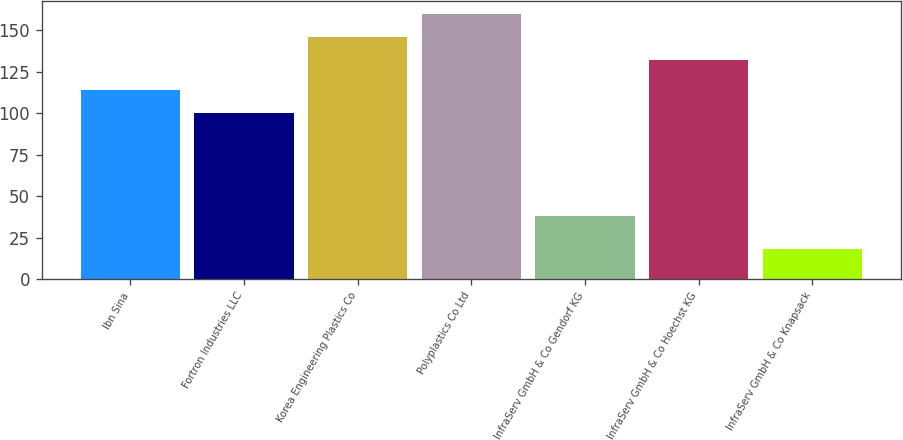<chart> <loc_0><loc_0><loc_500><loc_500><bar_chart><fcel>Ibn Sina<fcel>Fortron Industries LLC<fcel>Korea Engineering Plastics Co<fcel>Polyplastics Co Ltd<fcel>InfraServ GmbH & Co Gendorf KG<fcel>InfraServ GmbH & Co Hoechst KG<fcel>InfraServ GmbH & Co Knapsack<nl><fcel>113.8<fcel>100<fcel>145.8<fcel>159.6<fcel>38<fcel>132<fcel>18<nl></chart> 